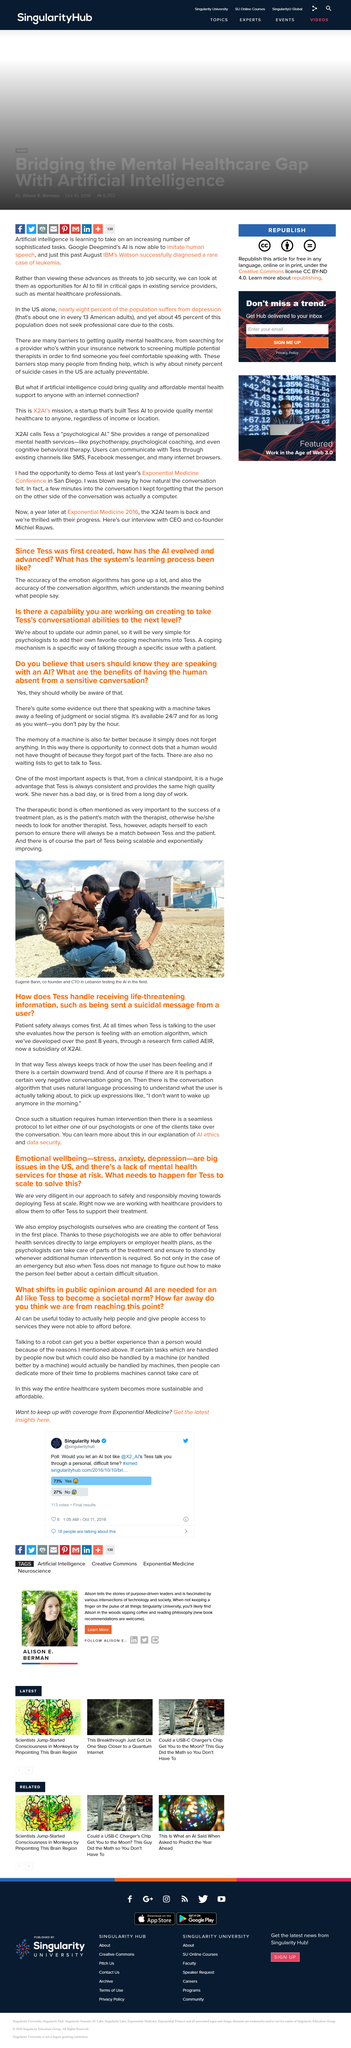Point out several critical features in this image. Emotional wellbeing is affected by stress, anxiety, and depression, which are three significant issues that can significantly impact an individual's mental and emotional state. Tess is always consistent and provides the same high quality work, making it a huge advantage for any task at hand. The individual in the photograph, who is a co-founder and CTO, is currently testing in Lebanon. The therapeutic bond is crucial for the success of a treatment plan. The Tess program uses a variety of doctors, including psychologists, to provide comprehensive medical care to its users. 